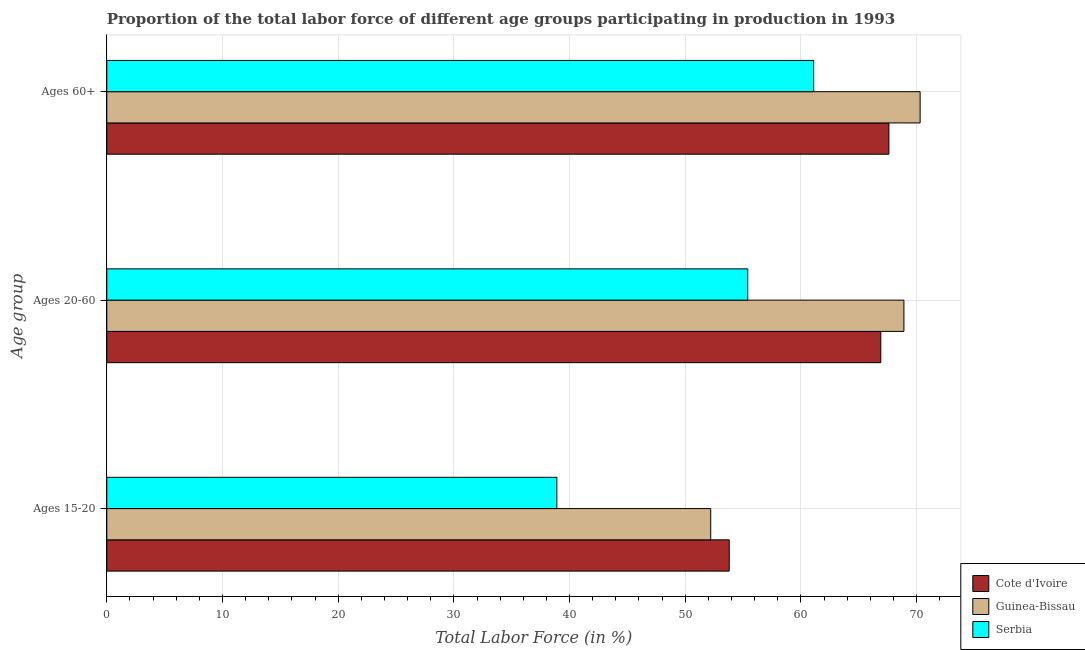How many groups of bars are there?
Offer a very short reply. 3. Are the number of bars per tick equal to the number of legend labels?
Provide a short and direct response. Yes. How many bars are there on the 1st tick from the bottom?
Your response must be concise. 3. What is the label of the 2nd group of bars from the top?
Give a very brief answer. Ages 20-60. What is the percentage of labor force above age 60 in Cote d'Ivoire?
Your response must be concise. 67.6. Across all countries, what is the maximum percentage of labor force within the age group 20-60?
Make the answer very short. 68.9. Across all countries, what is the minimum percentage of labor force within the age group 15-20?
Offer a very short reply. 38.9. In which country was the percentage of labor force above age 60 maximum?
Provide a succinct answer. Guinea-Bissau. In which country was the percentage of labor force within the age group 15-20 minimum?
Make the answer very short. Serbia. What is the total percentage of labor force within the age group 15-20 in the graph?
Your answer should be very brief. 144.9. What is the difference between the percentage of labor force above age 60 in Guinea-Bissau and that in Serbia?
Make the answer very short. 9.2. What is the difference between the percentage of labor force within the age group 15-20 in Serbia and the percentage of labor force within the age group 20-60 in Cote d'Ivoire?
Offer a terse response. -28. What is the average percentage of labor force above age 60 per country?
Your answer should be very brief. 66.33. What is the difference between the percentage of labor force within the age group 20-60 and percentage of labor force within the age group 15-20 in Serbia?
Provide a short and direct response. 16.5. In how many countries, is the percentage of labor force above age 60 greater than 40 %?
Your answer should be compact. 3. What is the ratio of the percentage of labor force above age 60 in Guinea-Bissau to that in Serbia?
Your response must be concise. 1.15. Is the percentage of labor force above age 60 in Serbia less than that in Guinea-Bissau?
Ensure brevity in your answer.  Yes. Is the difference between the percentage of labor force within the age group 15-20 in Serbia and Cote d'Ivoire greater than the difference between the percentage of labor force above age 60 in Serbia and Cote d'Ivoire?
Make the answer very short. No. What is the difference between the highest and the lowest percentage of labor force within the age group 20-60?
Offer a terse response. 13.5. In how many countries, is the percentage of labor force within the age group 20-60 greater than the average percentage of labor force within the age group 20-60 taken over all countries?
Provide a succinct answer. 2. Is the sum of the percentage of labor force above age 60 in Guinea-Bissau and Serbia greater than the maximum percentage of labor force within the age group 20-60 across all countries?
Ensure brevity in your answer.  Yes. What does the 2nd bar from the top in Ages 15-20 represents?
Make the answer very short. Guinea-Bissau. What does the 2nd bar from the bottom in Ages 60+ represents?
Keep it short and to the point. Guinea-Bissau. How many bars are there?
Your answer should be compact. 9. Are all the bars in the graph horizontal?
Offer a very short reply. Yes. What is the difference between two consecutive major ticks on the X-axis?
Provide a succinct answer. 10. Where does the legend appear in the graph?
Offer a very short reply. Bottom right. What is the title of the graph?
Ensure brevity in your answer.  Proportion of the total labor force of different age groups participating in production in 1993. Does "St. Lucia" appear as one of the legend labels in the graph?
Ensure brevity in your answer.  No. What is the label or title of the Y-axis?
Give a very brief answer. Age group. What is the Total Labor Force (in %) of Cote d'Ivoire in Ages 15-20?
Offer a terse response. 53.8. What is the Total Labor Force (in %) in Guinea-Bissau in Ages 15-20?
Keep it short and to the point. 52.2. What is the Total Labor Force (in %) in Serbia in Ages 15-20?
Ensure brevity in your answer.  38.9. What is the Total Labor Force (in %) in Cote d'Ivoire in Ages 20-60?
Make the answer very short. 66.9. What is the Total Labor Force (in %) of Guinea-Bissau in Ages 20-60?
Offer a terse response. 68.9. What is the Total Labor Force (in %) in Serbia in Ages 20-60?
Offer a very short reply. 55.4. What is the Total Labor Force (in %) in Cote d'Ivoire in Ages 60+?
Provide a succinct answer. 67.6. What is the Total Labor Force (in %) of Guinea-Bissau in Ages 60+?
Make the answer very short. 70.3. What is the Total Labor Force (in %) in Serbia in Ages 60+?
Offer a terse response. 61.1. Across all Age group, what is the maximum Total Labor Force (in %) of Cote d'Ivoire?
Your answer should be compact. 67.6. Across all Age group, what is the maximum Total Labor Force (in %) of Guinea-Bissau?
Your response must be concise. 70.3. Across all Age group, what is the maximum Total Labor Force (in %) in Serbia?
Make the answer very short. 61.1. Across all Age group, what is the minimum Total Labor Force (in %) of Cote d'Ivoire?
Your answer should be very brief. 53.8. Across all Age group, what is the minimum Total Labor Force (in %) of Guinea-Bissau?
Make the answer very short. 52.2. Across all Age group, what is the minimum Total Labor Force (in %) in Serbia?
Provide a succinct answer. 38.9. What is the total Total Labor Force (in %) of Cote d'Ivoire in the graph?
Give a very brief answer. 188.3. What is the total Total Labor Force (in %) in Guinea-Bissau in the graph?
Offer a terse response. 191.4. What is the total Total Labor Force (in %) of Serbia in the graph?
Make the answer very short. 155.4. What is the difference between the Total Labor Force (in %) in Cote d'Ivoire in Ages 15-20 and that in Ages 20-60?
Ensure brevity in your answer.  -13.1. What is the difference between the Total Labor Force (in %) of Guinea-Bissau in Ages 15-20 and that in Ages 20-60?
Your answer should be very brief. -16.7. What is the difference between the Total Labor Force (in %) of Serbia in Ages 15-20 and that in Ages 20-60?
Provide a short and direct response. -16.5. What is the difference between the Total Labor Force (in %) of Cote d'Ivoire in Ages 15-20 and that in Ages 60+?
Ensure brevity in your answer.  -13.8. What is the difference between the Total Labor Force (in %) in Guinea-Bissau in Ages 15-20 and that in Ages 60+?
Ensure brevity in your answer.  -18.1. What is the difference between the Total Labor Force (in %) of Serbia in Ages 15-20 and that in Ages 60+?
Make the answer very short. -22.2. What is the difference between the Total Labor Force (in %) in Cote d'Ivoire in Ages 20-60 and that in Ages 60+?
Keep it short and to the point. -0.7. What is the difference between the Total Labor Force (in %) in Cote d'Ivoire in Ages 15-20 and the Total Labor Force (in %) in Guinea-Bissau in Ages 20-60?
Ensure brevity in your answer.  -15.1. What is the difference between the Total Labor Force (in %) of Guinea-Bissau in Ages 15-20 and the Total Labor Force (in %) of Serbia in Ages 20-60?
Provide a short and direct response. -3.2. What is the difference between the Total Labor Force (in %) of Cote d'Ivoire in Ages 15-20 and the Total Labor Force (in %) of Guinea-Bissau in Ages 60+?
Make the answer very short. -16.5. What is the difference between the Total Labor Force (in %) in Cote d'Ivoire in Ages 15-20 and the Total Labor Force (in %) in Serbia in Ages 60+?
Offer a very short reply. -7.3. What is the difference between the Total Labor Force (in %) in Cote d'Ivoire in Ages 20-60 and the Total Labor Force (in %) in Guinea-Bissau in Ages 60+?
Your answer should be very brief. -3.4. What is the average Total Labor Force (in %) of Cote d'Ivoire per Age group?
Provide a succinct answer. 62.77. What is the average Total Labor Force (in %) of Guinea-Bissau per Age group?
Offer a very short reply. 63.8. What is the average Total Labor Force (in %) of Serbia per Age group?
Keep it short and to the point. 51.8. What is the difference between the Total Labor Force (in %) in Cote d'Ivoire and Total Labor Force (in %) in Guinea-Bissau in Ages 20-60?
Offer a very short reply. -2. What is the difference between the Total Labor Force (in %) in Cote d'Ivoire and Total Labor Force (in %) in Serbia in Ages 20-60?
Your answer should be very brief. 11.5. What is the difference between the Total Labor Force (in %) in Cote d'Ivoire and Total Labor Force (in %) in Guinea-Bissau in Ages 60+?
Offer a very short reply. -2.7. What is the ratio of the Total Labor Force (in %) in Cote d'Ivoire in Ages 15-20 to that in Ages 20-60?
Your answer should be compact. 0.8. What is the ratio of the Total Labor Force (in %) in Guinea-Bissau in Ages 15-20 to that in Ages 20-60?
Your answer should be compact. 0.76. What is the ratio of the Total Labor Force (in %) of Serbia in Ages 15-20 to that in Ages 20-60?
Provide a succinct answer. 0.7. What is the ratio of the Total Labor Force (in %) in Cote d'Ivoire in Ages 15-20 to that in Ages 60+?
Your answer should be compact. 0.8. What is the ratio of the Total Labor Force (in %) in Guinea-Bissau in Ages 15-20 to that in Ages 60+?
Keep it short and to the point. 0.74. What is the ratio of the Total Labor Force (in %) in Serbia in Ages 15-20 to that in Ages 60+?
Offer a very short reply. 0.64. What is the ratio of the Total Labor Force (in %) of Cote d'Ivoire in Ages 20-60 to that in Ages 60+?
Ensure brevity in your answer.  0.99. What is the ratio of the Total Labor Force (in %) in Guinea-Bissau in Ages 20-60 to that in Ages 60+?
Offer a terse response. 0.98. What is the ratio of the Total Labor Force (in %) of Serbia in Ages 20-60 to that in Ages 60+?
Give a very brief answer. 0.91. What is the difference between the highest and the second highest Total Labor Force (in %) of Cote d'Ivoire?
Give a very brief answer. 0.7. What is the difference between the highest and the second highest Total Labor Force (in %) in Serbia?
Your response must be concise. 5.7. What is the difference between the highest and the lowest Total Labor Force (in %) in Cote d'Ivoire?
Ensure brevity in your answer.  13.8. What is the difference between the highest and the lowest Total Labor Force (in %) in Serbia?
Your answer should be compact. 22.2. 